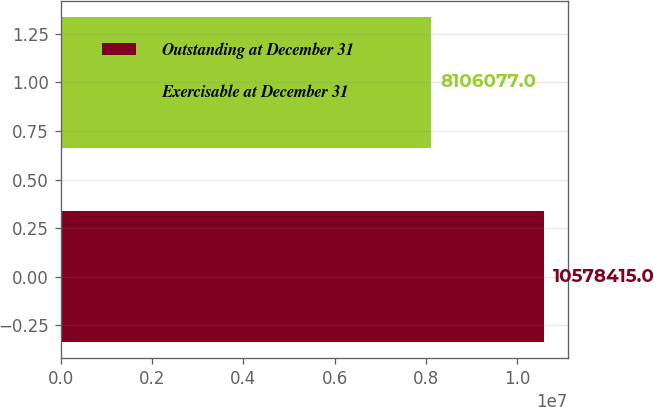Convert chart. <chart><loc_0><loc_0><loc_500><loc_500><bar_chart><fcel>Outstanding at December 31<fcel>Exercisable at December 31<nl><fcel>1.05784e+07<fcel>8.10608e+06<nl></chart> 